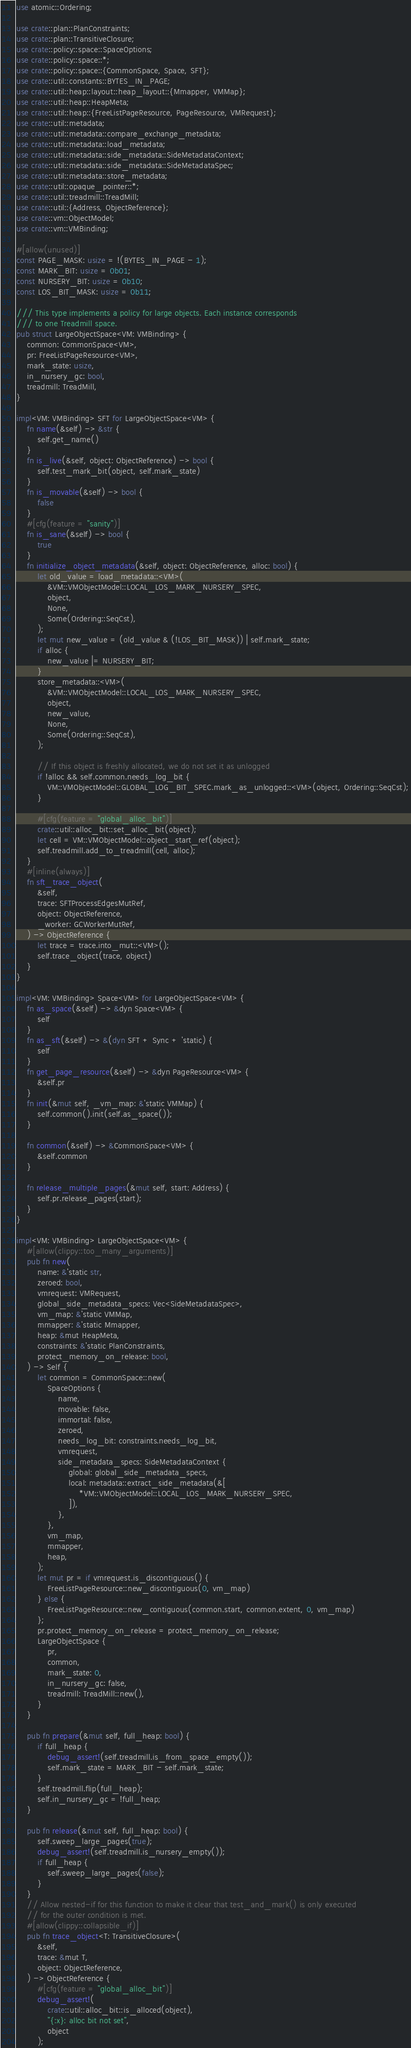<code> <loc_0><loc_0><loc_500><loc_500><_Rust_>use atomic::Ordering;

use crate::plan::PlanConstraints;
use crate::plan::TransitiveClosure;
use crate::policy::space::SpaceOptions;
use crate::policy::space::*;
use crate::policy::space::{CommonSpace, Space, SFT};
use crate::util::constants::BYTES_IN_PAGE;
use crate::util::heap::layout::heap_layout::{Mmapper, VMMap};
use crate::util::heap::HeapMeta;
use crate::util::heap::{FreeListPageResource, PageResource, VMRequest};
use crate::util::metadata;
use crate::util::metadata::compare_exchange_metadata;
use crate::util::metadata::load_metadata;
use crate::util::metadata::side_metadata::SideMetadataContext;
use crate::util::metadata::side_metadata::SideMetadataSpec;
use crate::util::metadata::store_metadata;
use crate::util::opaque_pointer::*;
use crate::util::treadmill::TreadMill;
use crate::util::{Address, ObjectReference};
use crate::vm::ObjectModel;
use crate::vm::VMBinding;

#[allow(unused)]
const PAGE_MASK: usize = !(BYTES_IN_PAGE - 1);
const MARK_BIT: usize = 0b01;
const NURSERY_BIT: usize = 0b10;
const LOS_BIT_MASK: usize = 0b11;

/// This type implements a policy for large objects. Each instance corresponds
/// to one Treadmill space.
pub struct LargeObjectSpace<VM: VMBinding> {
    common: CommonSpace<VM>,
    pr: FreeListPageResource<VM>,
    mark_state: usize,
    in_nursery_gc: bool,
    treadmill: TreadMill,
}

impl<VM: VMBinding> SFT for LargeObjectSpace<VM> {
    fn name(&self) -> &str {
        self.get_name()
    }
    fn is_live(&self, object: ObjectReference) -> bool {
        self.test_mark_bit(object, self.mark_state)
    }
    fn is_movable(&self) -> bool {
        false
    }
    #[cfg(feature = "sanity")]
    fn is_sane(&self) -> bool {
        true
    }
    fn initialize_object_metadata(&self, object: ObjectReference, alloc: bool) {
        let old_value = load_metadata::<VM>(
            &VM::VMObjectModel::LOCAL_LOS_MARK_NURSERY_SPEC,
            object,
            None,
            Some(Ordering::SeqCst),
        );
        let mut new_value = (old_value & (!LOS_BIT_MASK)) | self.mark_state;
        if alloc {
            new_value |= NURSERY_BIT;
        }
        store_metadata::<VM>(
            &VM::VMObjectModel::LOCAL_LOS_MARK_NURSERY_SPEC,
            object,
            new_value,
            None,
            Some(Ordering::SeqCst),
        );

        // If this object is freshly allocated, we do not set it as unlogged
        if !alloc && self.common.needs_log_bit {
            VM::VMObjectModel::GLOBAL_LOG_BIT_SPEC.mark_as_unlogged::<VM>(object, Ordering::SeqCst);
        }

        #[cfg(feature = "global_alloc_bit")]
        crate::util::alloc_bit::set_alloc_bit(object);
        let cell = VM::VMObjectModel::object_start_ref(object);
        self.treadmill.add_to_treadmill(cell, alloc);
    }
    #[inline(always)]
    fn sft_trace_object(
        &self,
        trace: SFTProcessEdgesMutRef,
        object: ObjectReference,
        _worker: GCWorkerMutRef,
    ) -> ObjectReference {
        let trace = trace.into_mut::<VM>();
        self.trace_object(trace, object)
    }
}

impl<VM: VMBinding> Space<VM> for LargeObjectSpace<VM> {
    fn as_space(&self) -> &dyn Space<VM> {
        self
    }
    fn as_sft(&self) -> &(dyn SFT + Sync + 'static) {
        self
    }
    fn get_page_resource(&self) -> &dyn PageResource<VM> {
        &self.pr
    }
    fn init(&mut self, _vm_map: &'static VMMap) {
        self.common().init(self.as_space());
    }

    fn common(&self) -> &CommonSpace<VM> {
        &self.common
    }

    fn release_multiple_pages(&mut self, start: Address) {
        self.pr.release_pages(start);
    }
}

impl<VM: VMBinding> LargeObjectSpace<VM> {
    #[allow(clippy::too_many_arguments)]
    pub fn new(
        name: &'static str,
        zeroed: bool,
        vmrequest: VMRequest,
        global_side_metadata_specs: Vec<SideMetadataSpec>,
        vm_map: &'static VMMap,
        mmapper: &'static Mmapper,
        heap: &mut HeapMeta,
        constraints: &'static PlanConstraints,
        protect_memory_on_release: bool,
    ) -> Self {
        let common = CommonSpace::new(
            SpaceOptions {
                name,
                movable: false,
                immortal: false,
                zeroed,
                needs_log_bit: constraints.needs_log_bit,
                vmrequest,
                side_metadata_specs: SideMetadataContext {
                    global: global_side_metadata_specs,
                    local: metadata::extract_side_metadata(&[
                        *VM::VMObjectModel::LOCAL_LOS_MARK_NURSERY_SPEC,
                    ]),
                },
            },
            vm_map,
            mmapper,
            heap,
        );
        let mut pr = if vmrequest.is_discontiguous() {
            FreeListPageResource::new_discontiguous(0, vm_map)
        } else {
            FreeListPageResource::new_contiguous(common.start, common.extent, 0, vm_map)
        };
        pr.protect_memory_on_release = protect_memory_on_release;
        LargeObjectSpace {
            pr,
            common,
            mark_state: 0,
            in_nursery_gc: false,
            treadmill: TreadMill::new(),
        }
    }

    pub fn prepare(&mut self, full_heap: bool) {
        if full_heap {
            debug_assert!(self.treadmill.is_from_space_empty());
            self.mark_state = MARK_BIT - self.mark_state;
        }
        self.treadmill.flip(full_heap);
        self.in_nursery_gc = !full_heap;
    }

    pub fn release(&mut self, full_heap: bool) {
        self.sweep_large_pages(true);
        debug_assert!(self.treadmill.is_nursery_empty());
        if full_heap {
            self.sweep_large_pages(false);
        }
    }
    // Allow nested-if for this function to make it clear that test_and_mark() is only executed
    // for the outer condition is met.
    #[allow(clippy::collapsible_if)]
    pub fn trace_object<T: TransitiveClosure>(
        &self,
        trace: &mut T,
        object: ObjectReference,
    ) -> ObjectReference {
        #[cfg(feature = "global_alloc_bit")]
        debug_assert!(
            crate::util::alloc_bit::is_alloced(object),
            "{:x}: alloc bit not set",
            object
        );</code> 